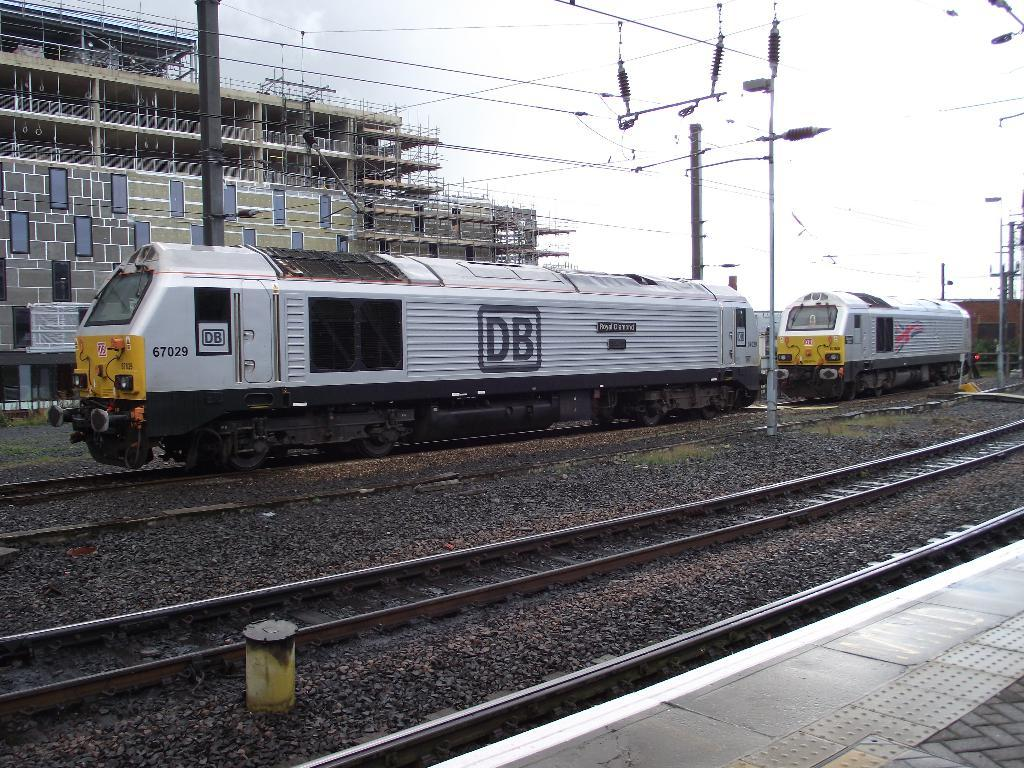What is the main subject of subject of the image? The main subject of the image is a building under construction. What other structures can be seen in the image? Electric poles, iron poles, and a platform are visible in the image. What type of transportation infrastructure is present in the image? Railway engines and tracks are in the image. What materials are visible in the image? Electric cables, stones, and iron poles are present in the image. What part of the natural environment is visible in the image? The sky is visible in the image. What type of beast can be seen roaming around the construction site in the image? There is no beast present in the image; it features a building under construction, electric poles, iron poles, railway engines, tracks, stones, a platform, and the sky. 